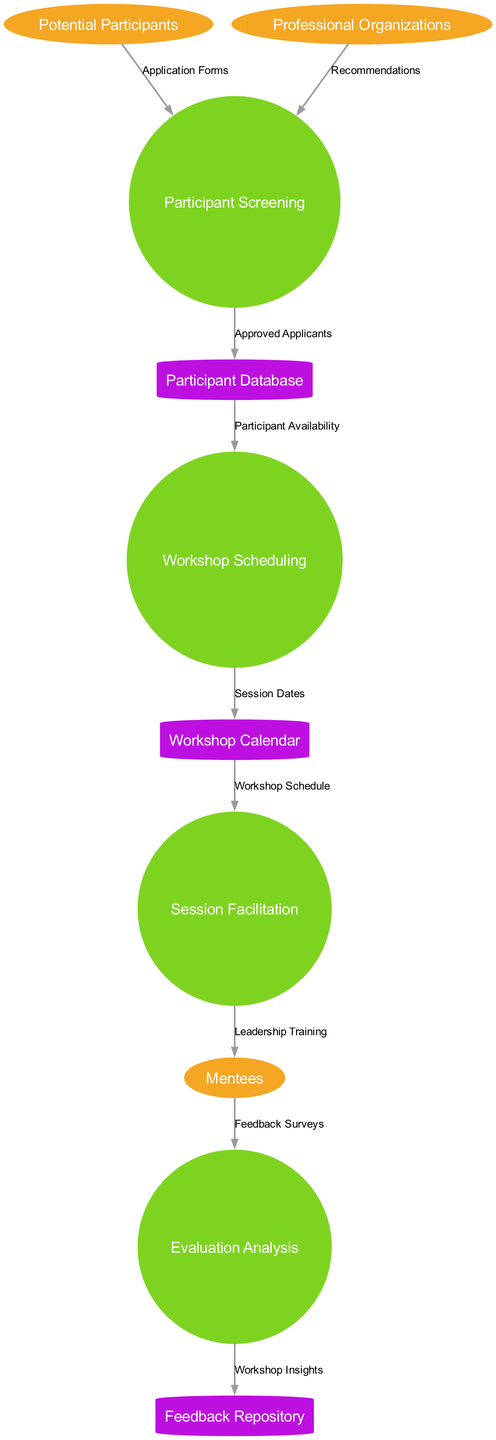What is the first step in the workshop process? The first step is "Participant Screening." In the diagram, "Participant Screening" is identified as the initial process. It acts as the gateway for managing applications from potential participants and recommendations from professional organizations.
Answer: Participant Screening How many external entities are represented in the diagram? There are three external entities indicated in the diagram: Potential Participants, Professional Organizations, and Mentees. They are represented in ellipses, identifying their roles related to the workshop process.
Answer: 3 What informs the "Participant Screening" process? "Application Forms" from Potential Participants and "Recommendations" from Professional Organizations inform the "Participant Screening" process. These data flows provide the necessary information for screening potential participants.
Answer: Application Forms and Recommendations What does the "Evaluation Analysis" process output to the "Feedback Repository"? The "Evaluation Analysis" process outputs "Workshop Insights" to the "Feedback Repository." This data flow indicates that insights gathered from the evaluation are stored for future reference.
Answer: Workshop Insights What data does the "Workshop Scheduling" process rely on? The "Workshop Scheduling" process relies on "Participant Availability" from the "Participant Database." This flow ensures that scheduling is based on the availability of accepted participants.
Answer: Participant Availability How are mentees affected by the "Session Facilitation" process? Mentees receive "Leadership Training" from the "Session Facilitation" process, indicating that they are the target audience for the training sessions conducted during the workshop.
Answer: Leadership Training What is the role of the "Workshop Calendar" in the diagram? The "Workshop Calendar" organizes and provides the "Workshop Schedule" to the "Session Facilitation" process. It acts as a reference for scheduling workshops, ensuring that session dates are well arranged.
Answer: Workshop Schedule Which process receives "Feedback Surveys," and from whom? The "Evaluation Analysis" process receives "Feedback Surveys" from Mentees. This indicates that the evaluation of the workshop is based on the feedback collected from the participants.
Answer: Evaluation Analysis from Mentees What shape represents data stores in this diagram? Data stores in this diagram are represented with a cylinder shape. This is a conventional representation used in data flow diagrams to illustrate stored information within the process.
Answer: Cylinder 